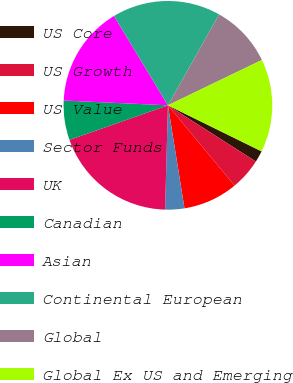Convert chart to OTSL. <chart><loc_0><loc_0><loc_500><loc_500><pie_chart><fcel>US Core<fcel>US Growth<fcel>US Value<fcel>Sector Funds<fcel>UK<fcel>Canadian<fcel>Asian<fcel>Continental European<fcel>Global<fcel>Global Ex US and Emerging<nl><fcel>1.78%<fcel>4.92%<fcel>8.49%<fcel>2.97%<fcel>19.19%<fcel>6.11%<fcel>15.62%<fcel>16.81%<fcel>9.68%<fcel>14.43%<nl></chart> 